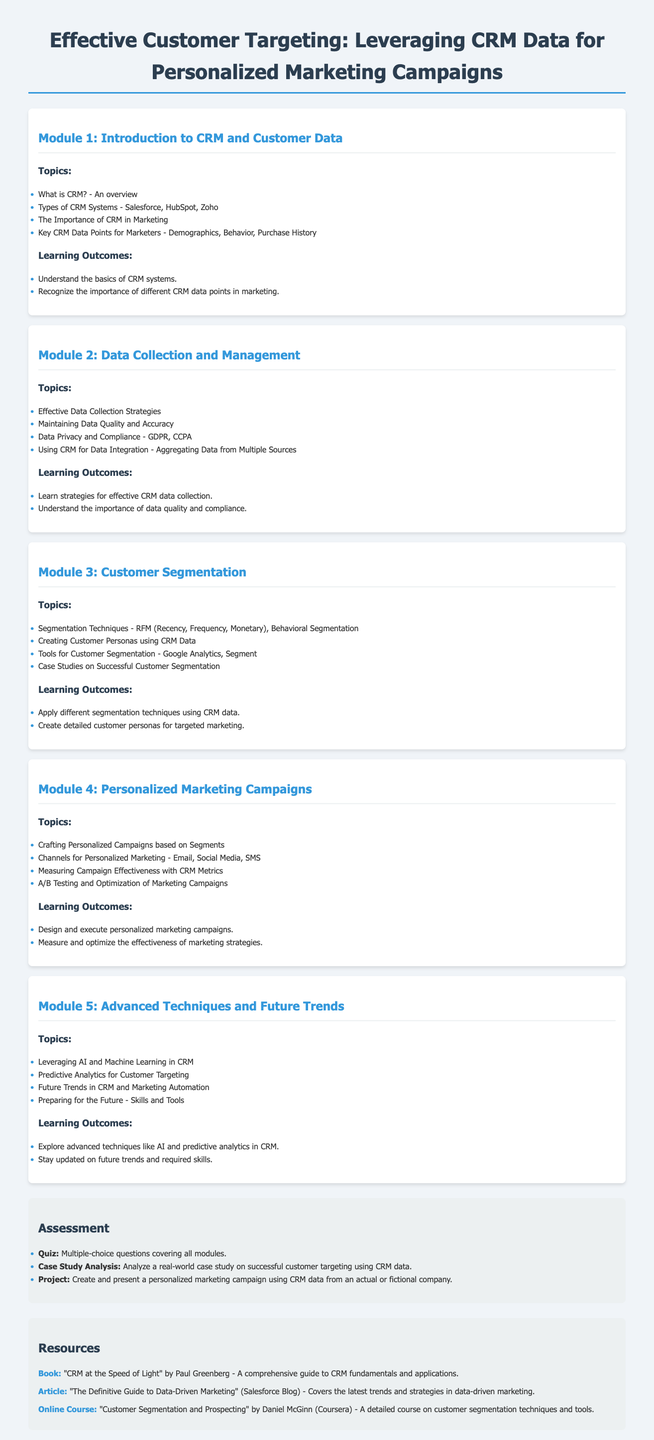What is the first module's title? The first module's title is prominently displayed at the beginning of the module section.
Answer: Introduction to CRM and Customer Data How many modules are in total? The document lists five distinct modules, each with its own set of topics and learning outcomes.
Answer: Five Which CRM system is mentioned in Module 1? Module 1 specifically lists Salesforce, HubSpot, and Zoho as examples of CRM systems.
Answer: Salesforce What technique is discussed in Module 3 for customer segmentation? The document mentions RFM (Recency, Frequency, Monetary) as a segmentation technique in Module 3.
Answer: RFM What is one of the channels for personalized marketing mentioned in Module 4? Module 4 lists various channels for personalized marketing, including email, social media, and SMS.
Answer: Email What is included in the assessment section? The assessment section outlines different types of evaluations, including a quiz and a case study analysis.
Answer: Quiz What is the title of a recommended book in the resources? The resources section highlights a specific book that serves as a guide related to CRM fundamentals.
Answer: CRM at the Speed of Light What learning outcome is associated with Module 5? The learning outcomes for Module 5 include exploring advanced techniques like AI and predictive analytics.
Answer: Explore advanced techniques like AI and predictive analytics in CRM Which compliance regulations are referenced in Module 2? Module 2 addresses regulations related to data privacy, referring specifically to GDPR and CCPA.
Answer: GDPR, CCPA 